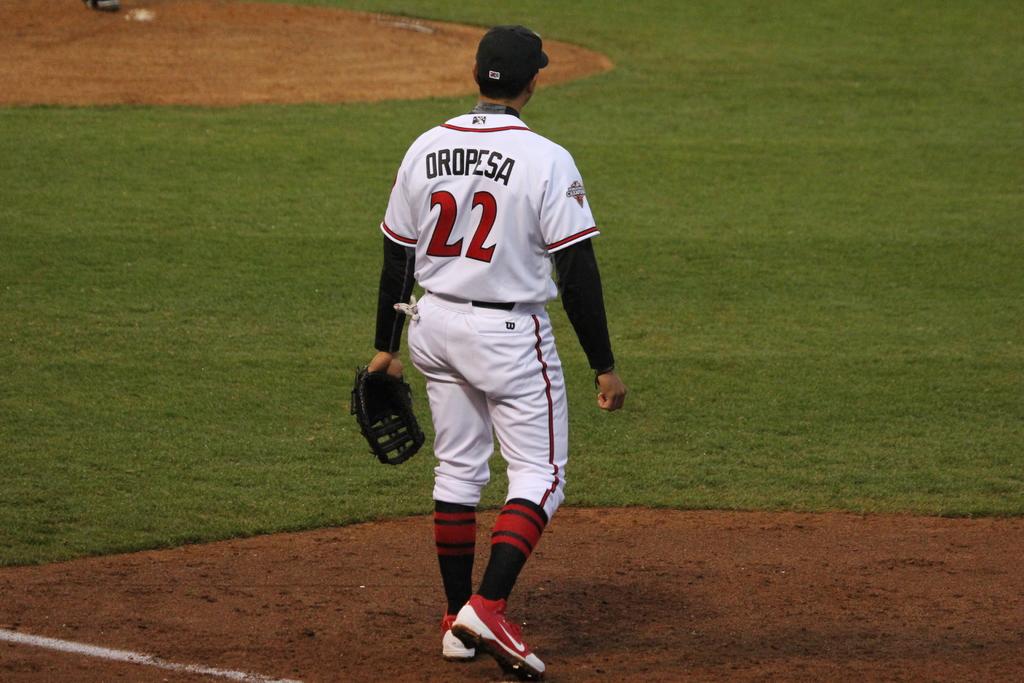What is the player's last name?
Offer a terse response. Oropesa. 